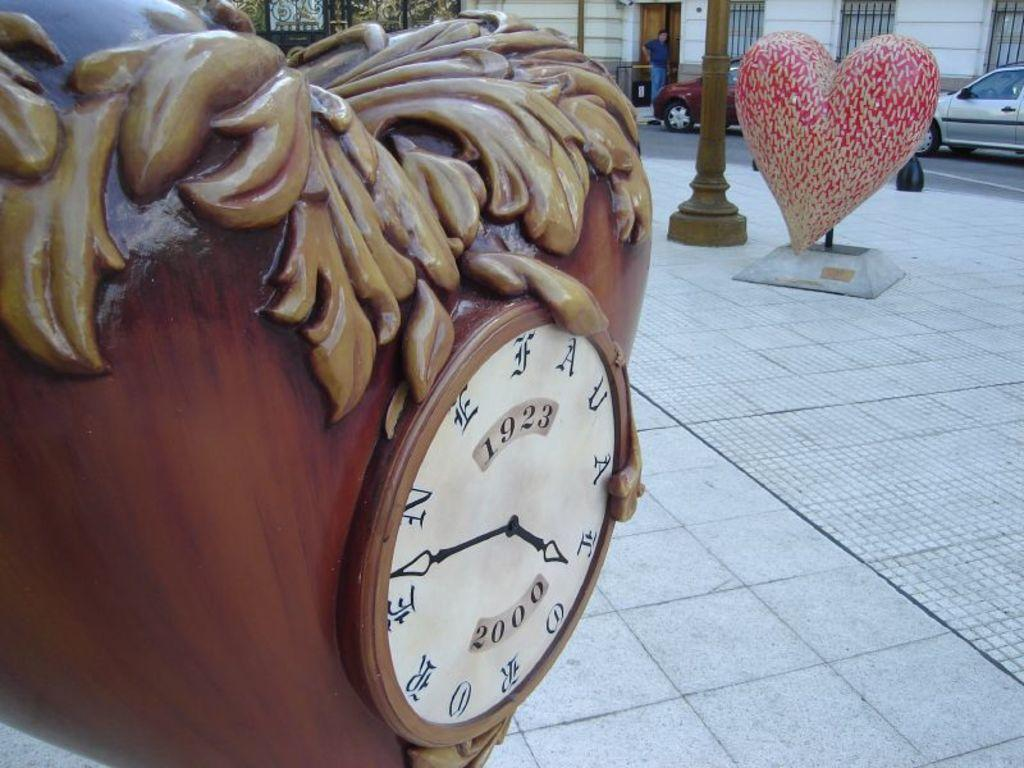What is the primary surface visible in the image? There is a ground in the image. What time-keeping device can be seen in the image? There is a clock in the image. What type of object made of wood is present in the image? There is a wooden object in the image. What shape is one of the objects in the image? There is a heart-shaped object in the image. Can you describe the background of the image? In the background of the image, there is a person, vehicles, poles, a wall, and windows. What type of bread is being used to make a loaf in the image? There is no bread or loaf present in the image. What type of pot is being used to cook a meal in the image? There is no pot or meal being cooked in the image. 